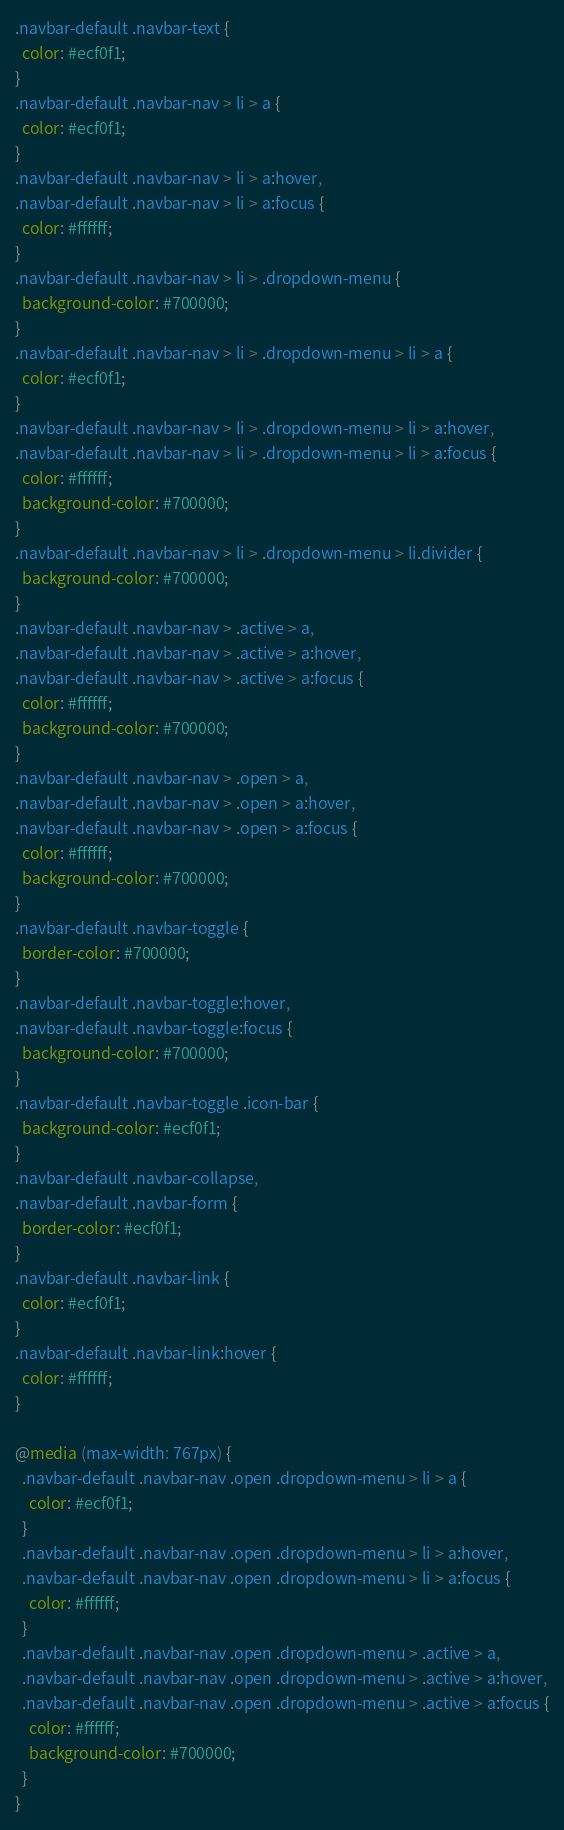Convert code to text. <code><loc_0><loc_0><loc_500><loc_500><_CSS_>.navbar-default .navbar-text {
  color: #ecf0f1;
}
.navbar-default .navbar-nav > li > a {
  color: #ecf0f1;
}
.navbar-default .navbar-nav > li > a:hover,
.navbar-default .navbar-nav > li > a:focus {
  color: #ffffff;
}
.navbar-default .navbar-nav > li > .dropdown-menu {
  background-color: #700000;
}
.navbar-default .navbar-nav > li > .dropdown-menu > li > a {
  color: #ecf0f1;
}
.navbar-default .navbar-nav > li > .dropdown-menu > li > a:hover,
.navbar-default .navbar-nav > li > .dropdown-menu > li > a:focus {
  color: #ffffff;
  background-color: #700000;
}
.navbar-default .navbar-nav > li > .dropdown-menu > li.divider {
  background-color: #700000;
}
.navbar-default .navbar-nav > .active > a,
.navbar-default .navbar-nav > .active > a:hover,
.navbar-default .navbar-nav > .active > a:focus {
  color: #ffffff;
  background-color: #700000;
}
.navbar-default .navbar-nav > .open > a,
.navbar-default .navbar-nav > .open > a:hover,
.navbar-default .navbar-nav > .open > a:focus {
  color: #ffffff;
  background-color: #700000;
}
.navbar-default .navbar-toggle {
  border-color: #700000;
}
.navbar-default .navbar-toggle:hover,
.navbar-default .navbar-toggle:focus {
  background-color: #700000;
}
.navbar-default .navbar-toggle .icon-bar {
  background-color: #ecf0f1;
}
.navbar-default .navbar-collapse,
.navbar-default .navbar-form {
  border-color: #ecf0f1;
}
.navbar-default .navbar-link {
  color: #ecf0f1;
}
.navbar-default .navbar-link:hover {
  color: #ffffff;
}

@media (max-width: 767px) {
  .navbar-default .navbar-nav .open .dropdown-menu > li > a {
    color: #ecf0f1;
  }
  .navbar-default .navbar-nav .open .dropdown-menu > li > a:hover,
  .navbar-default .navbar-nav .open .dropdown-menu > li > a:focus {
    color: #ffffff;
  }
  .navbar-default .navbar-nav .open .dropdown-menu > .active > a,
  .navbar-default .navbar-nav .open .dropdown-menu > .active > a:hover,
  .navbar-default .navbar-nav .open .dropdown-menu > .active > a:focus {
    color: #ffffff;
    background-color: #700000;
  }
}
</code> 